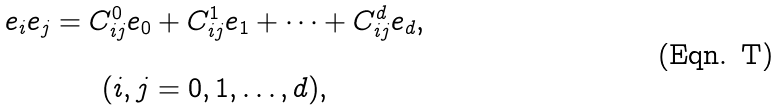Convert formula to latex. <formula><loc_0><loc_0><loc_500><loc_500>\begin{array} { c } e _ { i } e _ { j } = C _ { i j } ^ { 0 } e _ { 0 } + C _ { i j } ^ { 1 } e _ { 1 } + \dots + C _ { i j } ^ { d } e _ { d } , \\ \\ ( i , j = 0 , 1 , \dots , d ) , \end{array}</formula> 